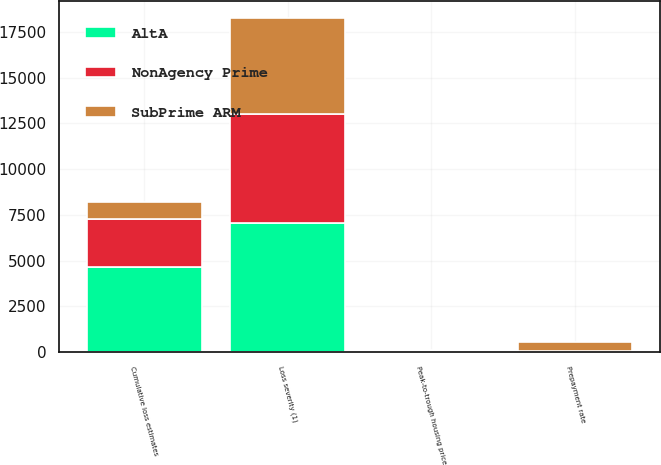<chart> <loc_0><loc_0><loc_500><loc_500><stacked_bar_chart><ecel><fcel>Prepayment rate<fcel>Cumulative loss estimates<fcel>Loss severity (1)<fcel>Peak-to-trough housing price<nl><fcel>AltA<fcel>13<fcel>4654<fcel>7072<fcel>35<nl><fcel>NonAgency Prime<fcel>26<fcel>2639<fcel>5961<fcel>35<nl><fcel>SubPrime ARM<fcel>510<fcel>919<fcel>5253<fcel>35<nl></chart> 